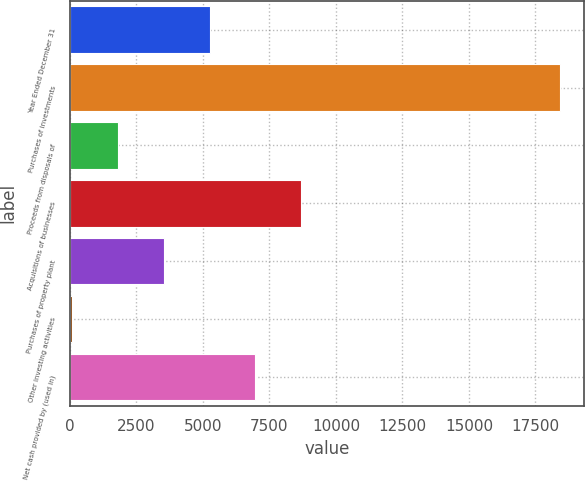<chart> <loc_0><loc_0><loc_500><loc_500><bar_chart><fcel>Year Ended December 31<fcel>Purchases of investments<fcel>Proceeds from disposals of<fcel>Acquisitions of businesses<fcel>Purchases of property plant<fcel>Other investing activities<fcel>Net cash provided by (used in)<nl><fcel>5253.9<fcel>18414.3<fcel>1813.3<fcel>8694.5<fcel>3533.6<fcel>93<fcel>6974.2<nl></chart> 